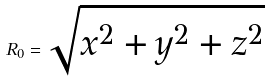<formula> <loc_0><loc_0><loc_500><loc_500>R _ { 0 } = \sqrt { x ^ { 2 } + y ^ { 2 } + z ^ { 2 } }</formula> 